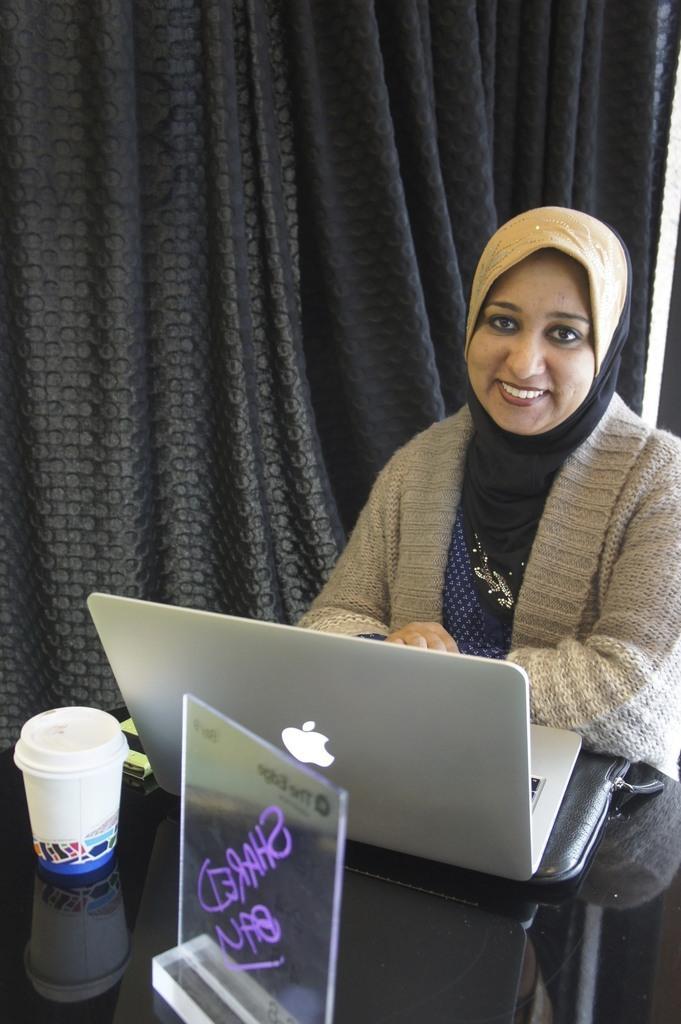Please provide a concise description of this image. At the bottom we can see laptop, cup, mobile, memorandum and table. In the middle of the picture we can see a woman. At the top there are curtains. 